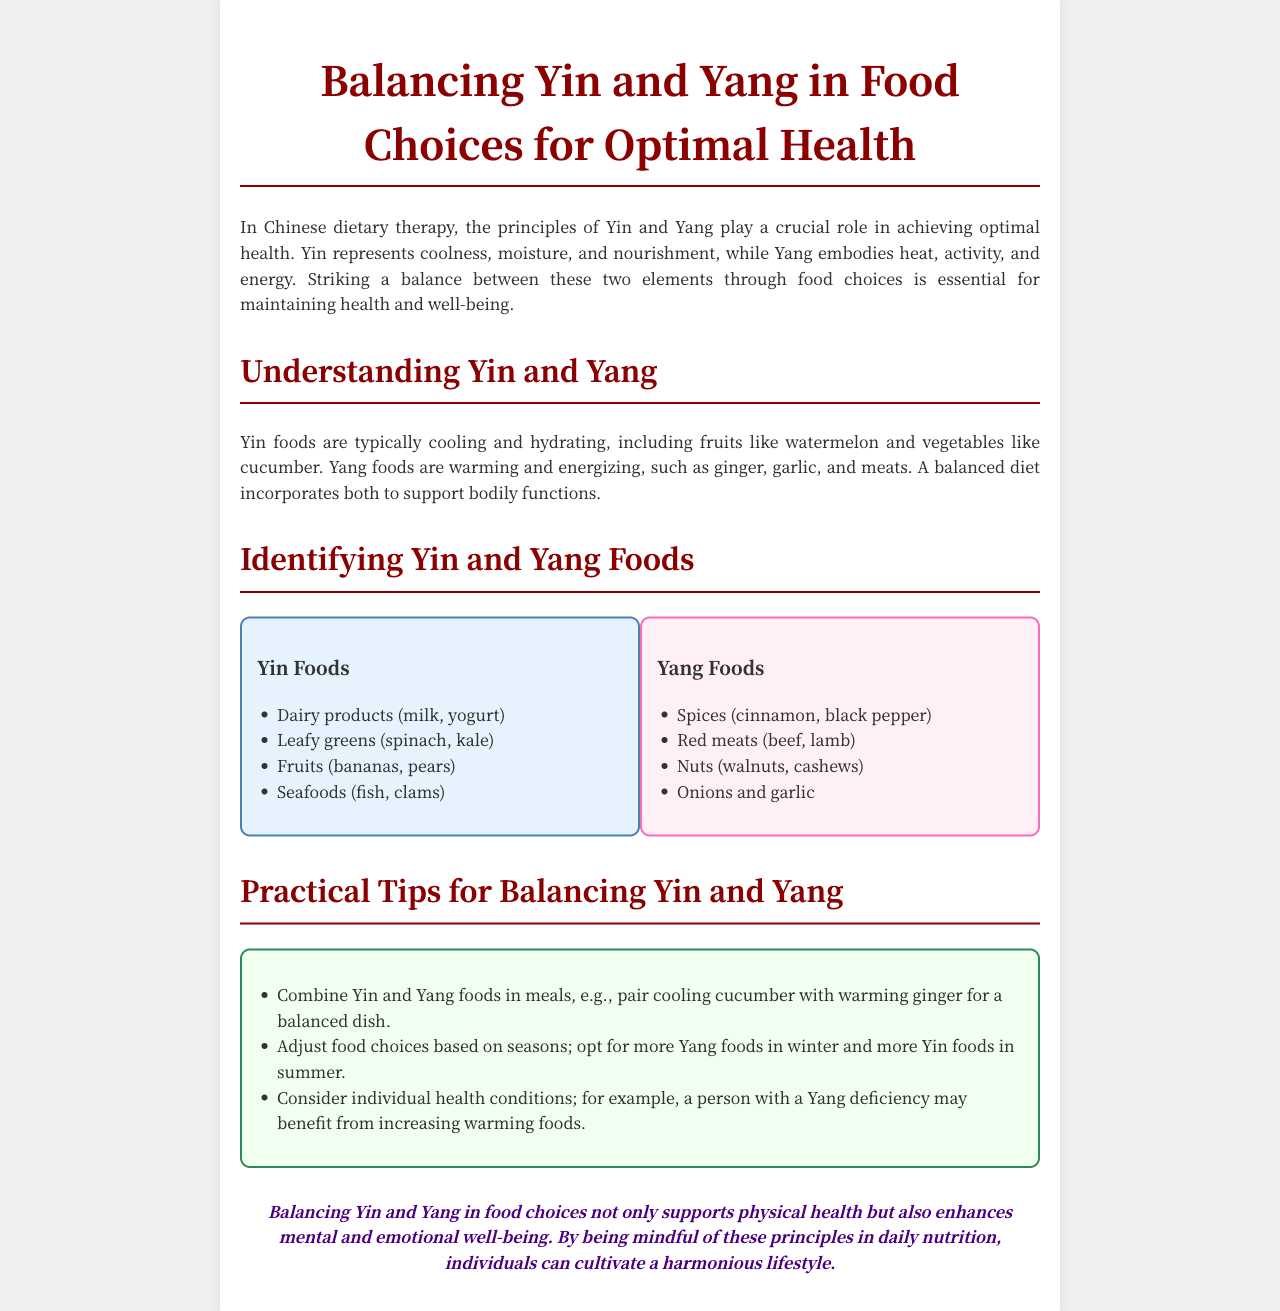What is the primary role of Yin and Yang in nutrition? The primary role of Yin and Yang in nutrition is to achieve optimal health.
Answer: optimal health Which types of foods are considered Yin? Yin foods are described in the document as typically cooling and hydrating foods.
Answer: cooling and hydrating Name one Yang food mentioned in the document. The document lists several Yang foods; one example is red meats.
Answer: red meats What advice is given for food choices in winter? The document suggests increasing the intake of Yang foods in winter.
Answer: Yang foods How does balancing Yin and Yang relate to well-being? Balancing Yin and Yang in food choices supports physical health and enhances mental and emotional well-being.
Answer: enhances well-being What is paired with cucumber for a balanced dish? The document suggests pairing cooling cucumber with warming ginger for a balanced dish.
Answer: warming ginger List one type of food from the Yin section. The document lists dairy products as one type of Yin food.
Answer: dairy products What is a practical tip for adjusting food choices? One practical tip is to adjust food choices based on seasons.
Answer: based on seasons 